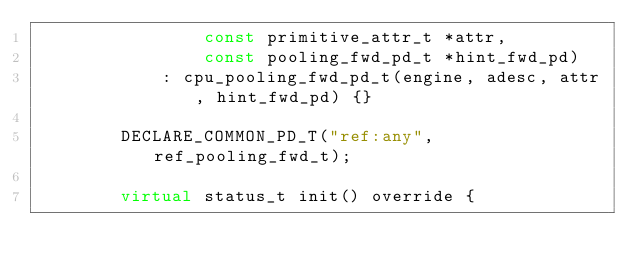<code> <loc_0><loc_0><loc_500><loc_500><_C++_>                const primitive_attr_t *attr,
                const pooling_fwd_pd_t *hint_fwd_pd)
            : cpu_pooling_fwd_pd_t(engine, adesc, attr, hint_fwd_pd) {}

        DECLARE_COMMON_PD_T("ref:any", ref_pooling_fwd_t);

        virtual status_t init() override {</code> 